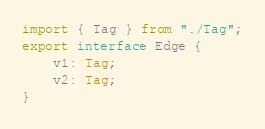<code> <loc_0><loc_0><loc_500><loc_500><_TypeScript_>import { Tag } from "./Tag";
export interface Edge {
    v1: Tag;
    v2: Tag;
}
</code> 